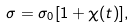Convert formula to latex. <formula><loc_0><loc_0><loc_500><loc_500>\sigma = \sigma _ { 0 } [ 1 + \chi ( t ) ] ,</formula> 